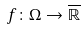<formula> <loc_0><loc_0><loc_500><loc_500>f \colon \Omega \rightarrow \overline { \mathbb { R } }</formula> 